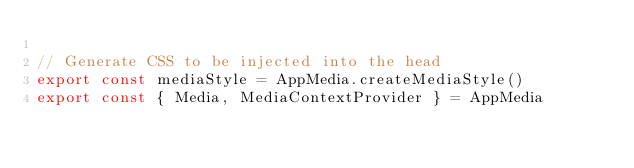<code> <loc_0><loc_0><loc_500><loc_500><_JavaScript_>
// Generate CSS to be injected into the head
export const mediaStyle = AppMedia.createMediaStyle()
export const { Media, MediaContextProvider } = AppMedia
</code> 